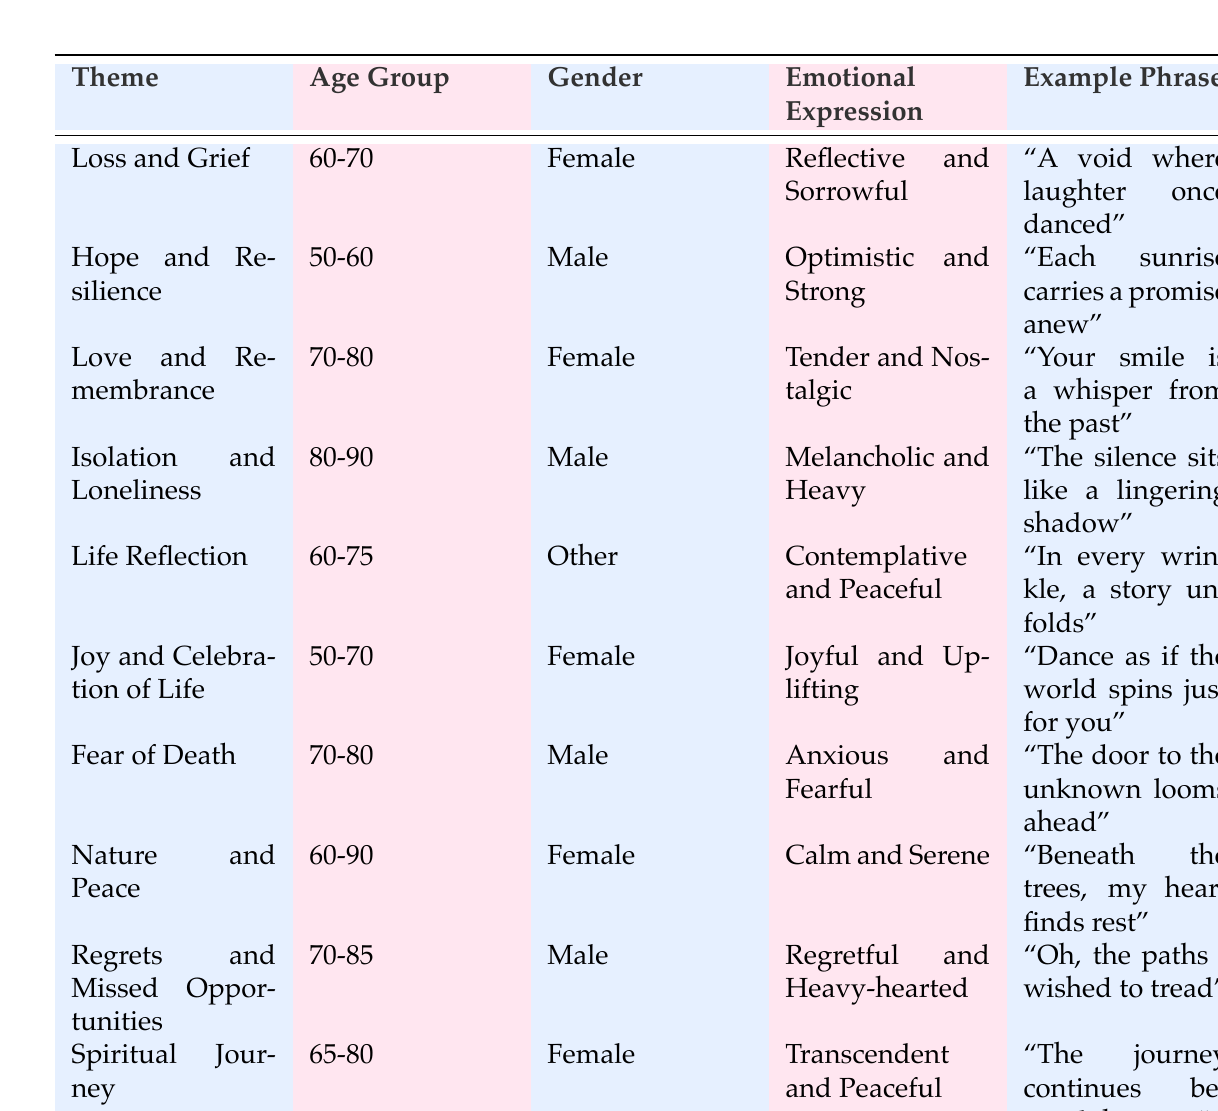What is the emotional expression associated with the theme "Loss and Grief"? The table indicates that the emotional expression for the theme "Loss and Grief" is "Reflective and Sorrowful".
Answer: Reflective and Sorrowful How many themes are associated with female patients aged 60-70? There are two themes listed for female patients aged 60-70: "Loss and Grief" and "Joy and Celebration of Life".
Answer: 2 Is there a theme that involves a male patient aged 80-90? Yes, the theme "Isolation and Loneliness" is associated with a male patient aged 80-90.
Answer: Yes What emotional expressions are linked to male patients aged 70-80 in the table? For male patients aged 70-80, the emotional expressions linked to themes are "Anxious and Fearful" for the theme "Fear of Death" and "Regretful and Heavy-hearted" for the theme "Regrets and Missed Opportunities".
Answer: Anxious and Fearful; Regretful and Heavy-hearted Which age group has the highest diversity of themes represented? The age group "60-90" has the highest diversity of themes represented, including "Nature and Peace" and a reflection theme. There are four different themes in this age range, which encompasses some of the themes from other groups as well.
Answer: 60-90 What is the example phrase for the theme "Nature and Peace"? The example phrase for the theme "Nature and Peace" is "Beneath the trees, my heart finds rest".
Answer: "Beneath the trees, my heart finds rest" How many emotional expressions are categorized as "Peaceful" or "Calm"? There are three emotional expressions categorized as "Peaceful" or "Calm": "Contemplative and Peaceful", "Calm and Serene", and "Transcendent and Peaceful".
Answer: 3 Which themes express feelings of regret? The themes that express feelings of regret are "Regrets and Missed Opportunities" and "Fear of Death".
Answer: Regrets and Missed Opportunities; Fear of Death Is the theme "Spiritual Journey" linked to a female patient? Yes, the theme "Spiritual Journey" is linked to a female patient aged 65-80.
Answer: Yes 